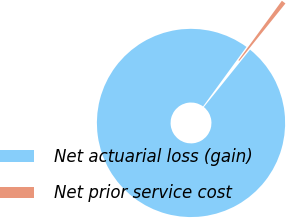<chart> <loc_0><loc_0><loc_500><loc_500><pie_chart><fcel>Net actuarial loss (gain)<fcel>Net prior service cost<nl><fcel>99.24%<fcel>0.76%<nl></chart> 